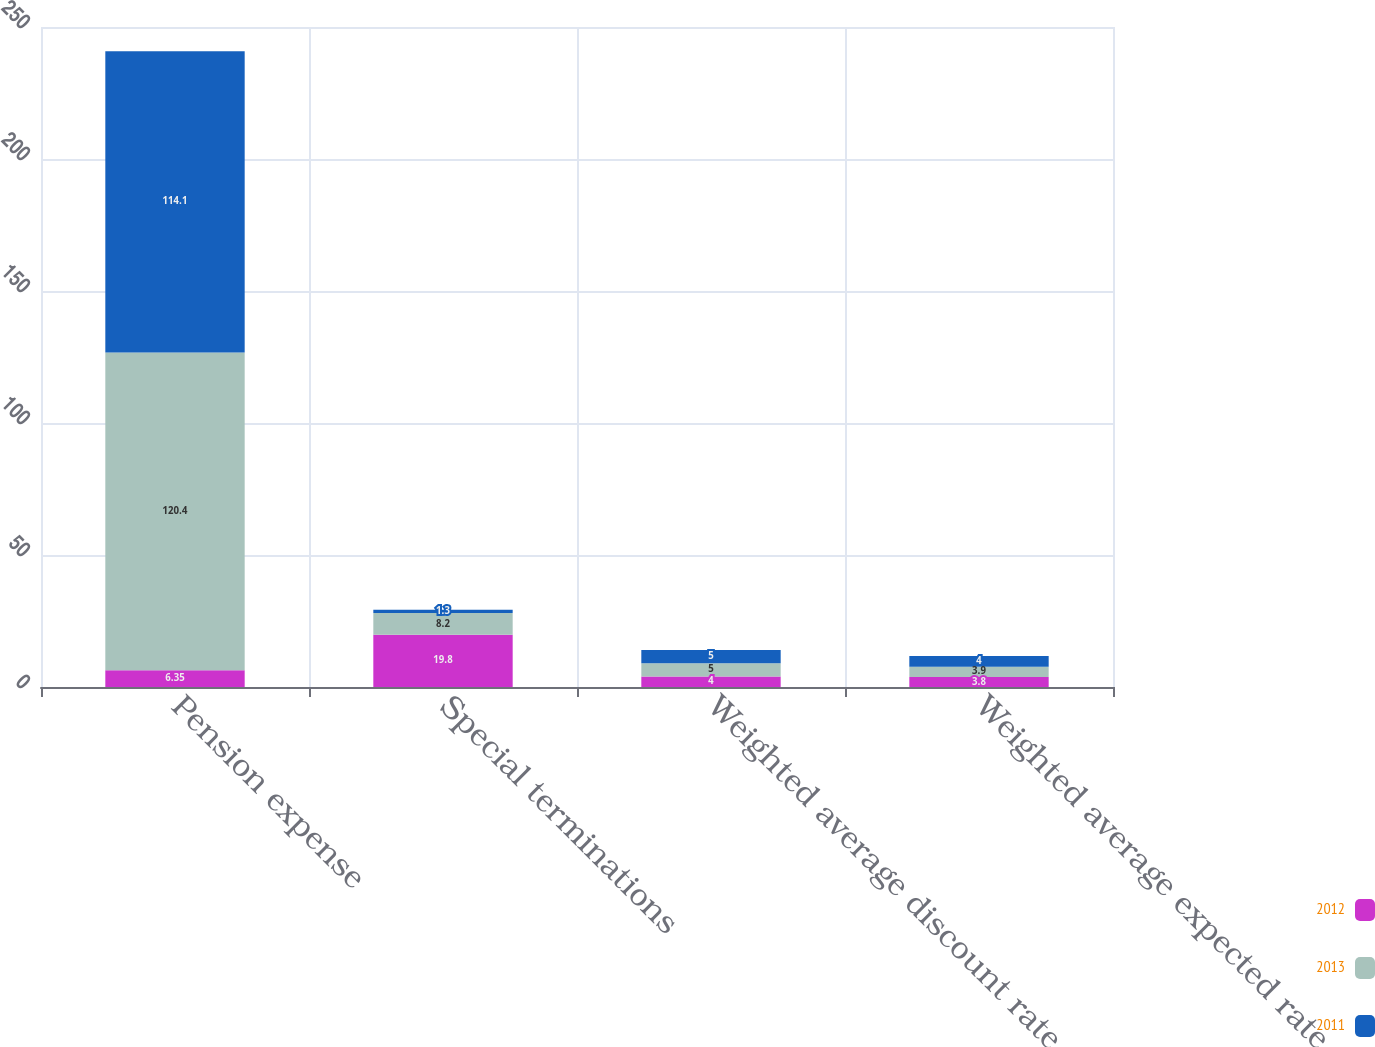<chart> <loc_0><loc_0><loc_500><loc_500><stacked_bar_chart><ecel><fcel>Pension expense<fcel>Special terminations<fcel>Weighted average discount rate<fcel>Weighted average expected rate<nl><fcel>2012<fcel>6.35<fcel>19.8<fcel>4<fcel>3.8<nl><fcel>2013<fcel>120.4<fcel>8.2<fcel>5<fcel>3.9<nl><fcel>2011<fcel>114.1<fcel>1.3<fcel>5<fcel>4<nl></chart> 